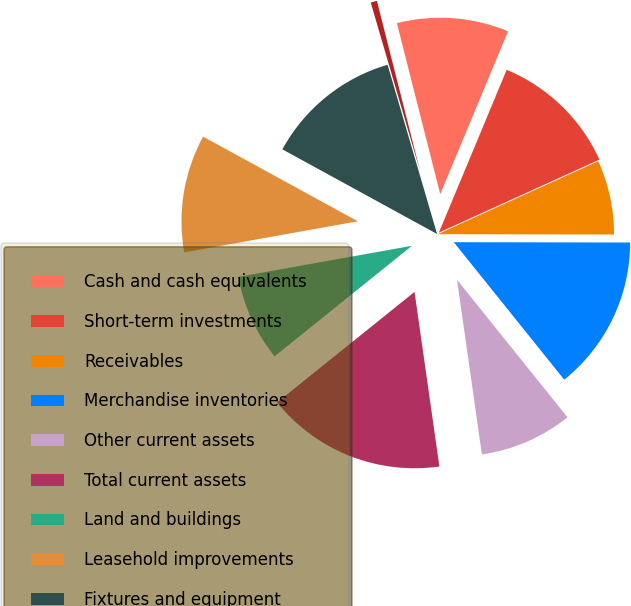Convert chart. <chart><loc_0><loc_0><loc_500><loc_500><pie_chart><fcel>Cash and cash equivalents<fcel>Short-term investments<fcel>Receivables<fcel>Merchandise inventories<fcel>Other current assets<fcel>Total current assets<fcel>Land and buildings<fcel>Leasehold improvements<fcel>Fixtures and equipment<fcel>Property under capital lease<nl><fcel>10.23%<fcel>11.93%<fcel>6.82%<fcel>14.2%<fcel>8.52%<fcel>16.47%<fcel>7.96%<fcel>10.79%<fcel>12.5%<fcel>0.58%<nl></chart> 